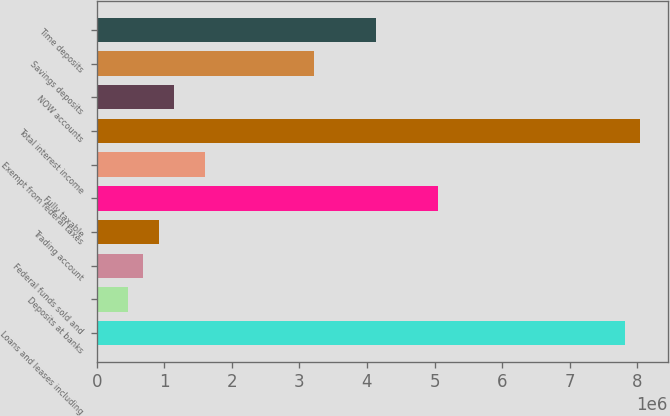<chart> <loc_0><loc_0><loc_500><loc_500><bar_chart><fcel>Loans and leases including<fcel>Deposits at banks<fcel>Federal funds sold and<fcel>Trading account<fcel>Fully taxable<fcel>Exempt from federal taxes<fcel>Total interest income<fcel>NOW accounts<fcel>Savings deposits<fcel>Time deposits<nl><fcel>7.81567e+06<fcel>459751<fcel>689624<fcel>919496<fcel>5.0572e+06<fcel>1.60911e+06<fcel>8.04555e+06<fcel>1.14937e+06<fcel>3.21822e+06<fcel>4.13771e+06<nl></chart> 